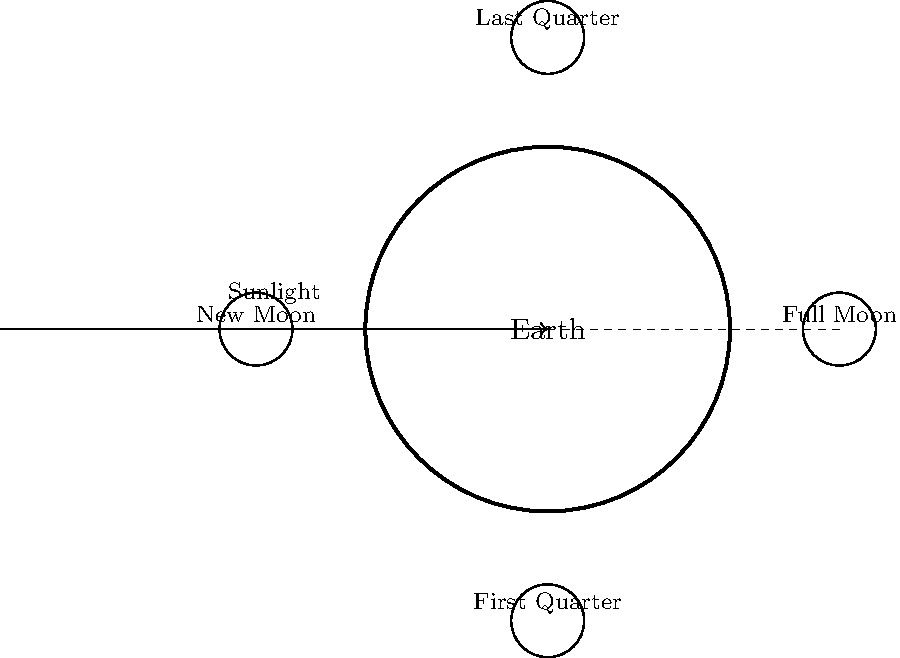As a strength and conditioning coach incorporating hormone regulation techniques, understanding natural cycles is crucial. The Moon's phases can influence hormone levels and potentially affect athletic performance. Explain the relationship between the Moon's phases and Earth's position relative to the Sun, and identify which phase occurs when the Moon is between Earth and the Sun. To understand the relationship between Moon phases and Earth's position:

1. Earth's position: Earth is at the center of the diagram, rotating on its axis.

2. Sun's position: The Sun is located to the left of Earth, providing constant illumination.

3. Moon's orbit: The Moon orbits Earth counterclockwise in about 29.5 days.

4. Illumination: The Sun always illuminates half of the Moon's surface, but we see different amounts based on the Moon's position relative to Earth and the Sun.

5. Phases:
   a) Full Moon: Occurs when Earth is between the Sun and Moon. We see the fully illuminated face of the Moon.
   b) Last Quarter: The Moon is 90° to the left of the Earth-Sun line. Half of the visible face is illuminated.
   c) New Moon: The Moon is between Earth and the Sun. The illuminated side faces away from Earth, so we see no illuminated surface.
   d) First Quarter: The Moon is 90° to the right of the Earth-Sun line. Half of the visible face is illuminated.

6. Earth-Moon-Sun alignment: When the Moon is between Earth and the Sun, it's in the New Moon phase.

This cycle's understanding can help in planning training schedules that align with natural hormone fluctuations, potentially optimizing athletic performance.
Answer: New Moon 